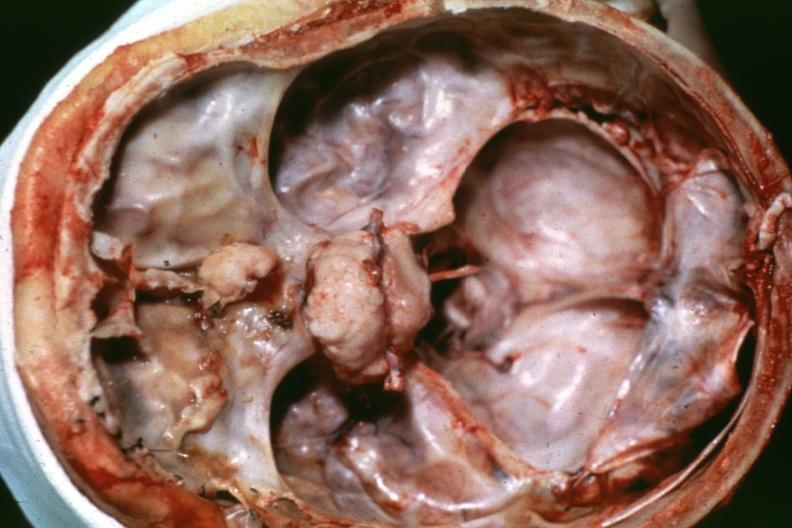what is present?
Answer the question using a single word or phrase. Bone, calvarium 